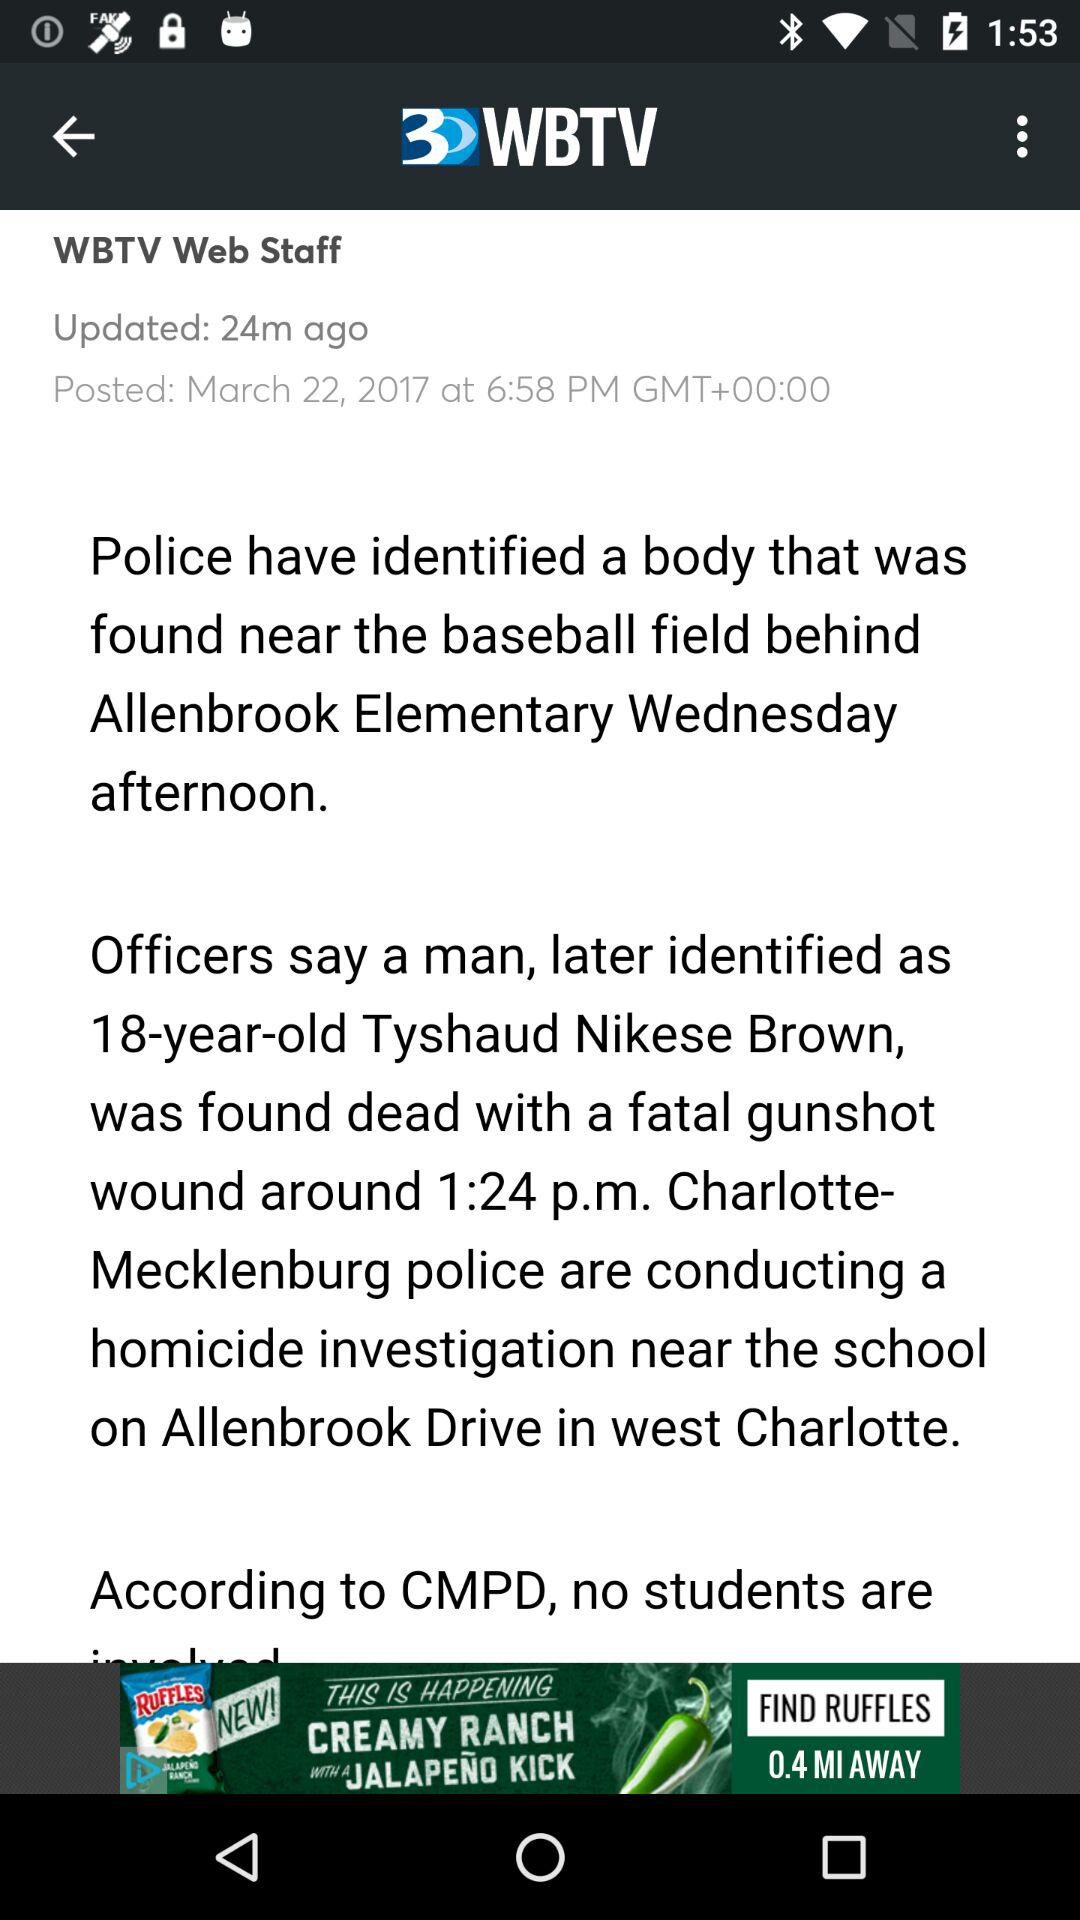What is the name of the application? The name of the application is "WBTV". 